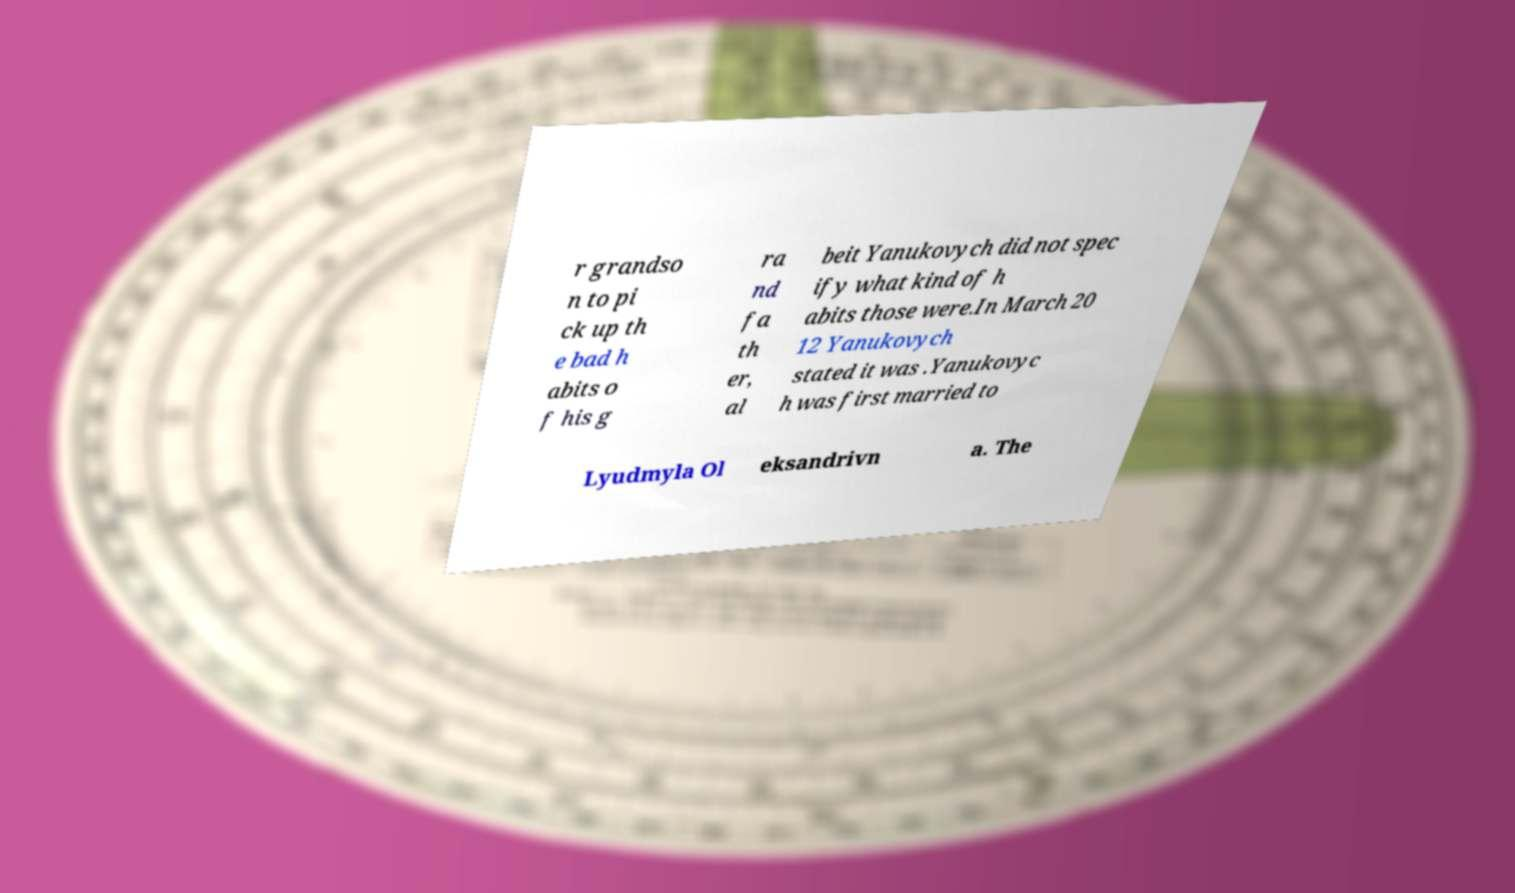Can you accurately transcribe the text from the provided image for me? r grandso n to pi ck up th e bad h abits o f his g ra nd fa th er, al beit Yanukovych did not spec ify what kind of h abits those were.In March 20 12 Yanukovych stated it was .Yanukovyc h was first married to Lyudmyla Ol eksandrivn a. The 